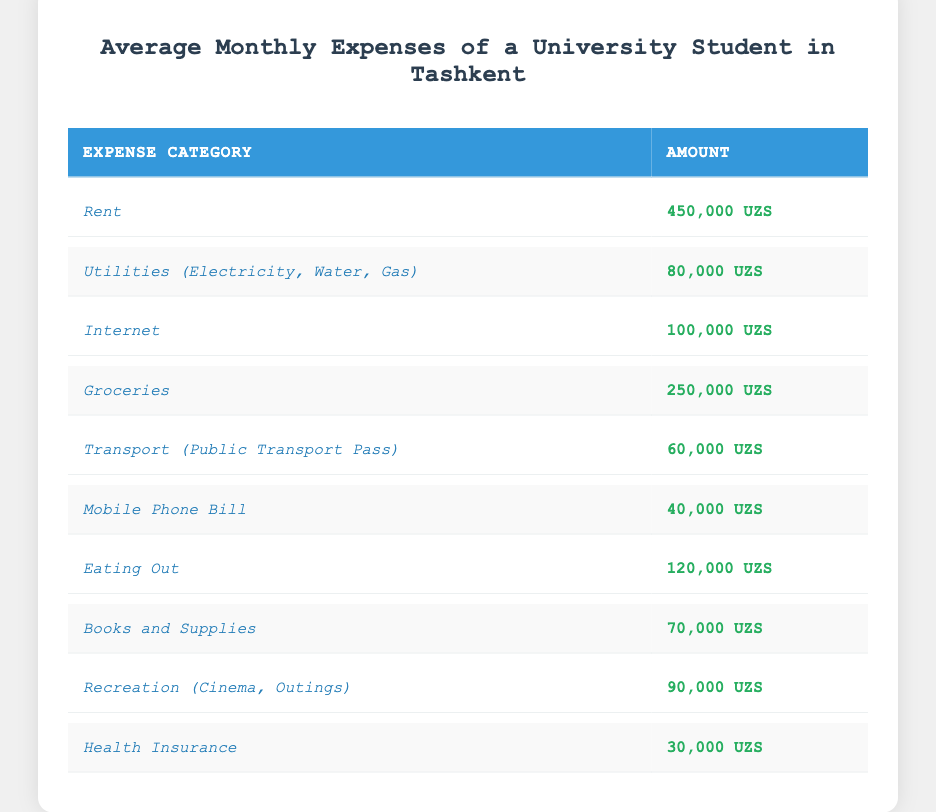What is the total amount spent on groceries and eating out? The amount for groceries is 250,000 UZS and for eating out is 120,000 UZS. Adding these together gives 250,000 + 120,000 = 370,000 UZS.
Answer: 370,000 UZS How much does a student spend on health insurance? According to the table, the health insurance expense is listed as 30,000 UZS.
Answer: 30,000 UZS What is the category with the highest expense? By examining the table, the highest expense category is Rent, which is 450,000 UZS.
Answer: Rent Are the total expenses for internet and mobile phone bill greater than the amount spent on utilities? The total for internet (100,000 UZS) and mobile phone bill (40,000 UZS) is 100,000 + 40,000 = 140,000 UZS. The utilities expense is 80,000 UZS. Since 140,000 > 80,000, the answer is yes.
Answer: Yes What is the average expense across all categories? First, we need to sum all expenses: 450,000 + 80,000 + 100,000 + 250,000 + 60,000 + 40,000 + 120,000 + 70,000 + 90,000 + 30,000 = 1,250,000 UZS. There are 10 categories, so the average is 1,250,000 / 10 = 125,000 UZS.
Answer: 125,000 UZS How much more is spent on rent compared to health insurance? The rent expense is 450,000 UZS and health insurance is 30,000 UZS. The difference is calculated as 450,000 - 30,000 = 420,000 UZS.
Answer: 420,000 UZS Is the combined expense for transport and books less than the amount spent on groceries? The transport expense is 60,000 UZS and books are 70,000 UZS, so 60,000 + 70,000 = 130,000 UZS. Since 130,000 < 250,000, the answer is yes.
Answer: Yes What percentage of the total expenses is allocated towards recreation? Total expenses amount to 1,250,000 UZS, and recreation expenses are 90,000 UZS. To find the percentage, calculate (90,000 / 1,250,000) * 100 = 7.2%.
Answer: 7.2% How much do students spend on utilities compared to the amount spent on a mobile phone bill? Utilities cost 80,000 UZS, while the mobile phone bill costs 40,000 UZS. Comparing these, 80,000 is twice the amount of 40,000. Therefore, utilities are greater.
Answer: Utilities are greater 